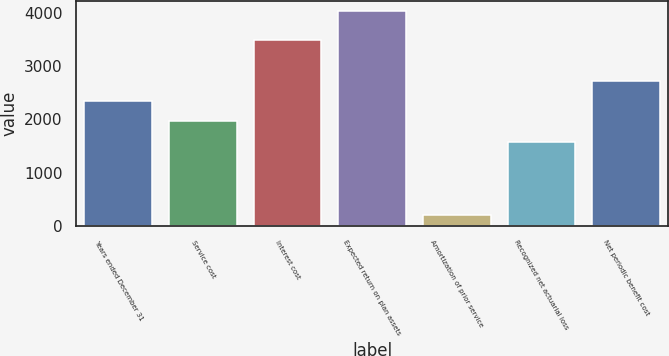Convert chart to OTSL. <chart><loc_0><loc_0><loc_500><loc_500><bar_chart><fcel>Years ended December 31<fcel>Service cost<fcel>Interest cost<fcel>Expected return on plan assets<fcel>Amortization of prior service<fcel>Recognized net actuarial loss<fcel>Net periodic benefit cost<nl><fcel>2344<fcel>1960.5<fcel>3494.5<fcel>4031<fcel>196<fcel>1577<fcel>2727.5<nl></chart> 